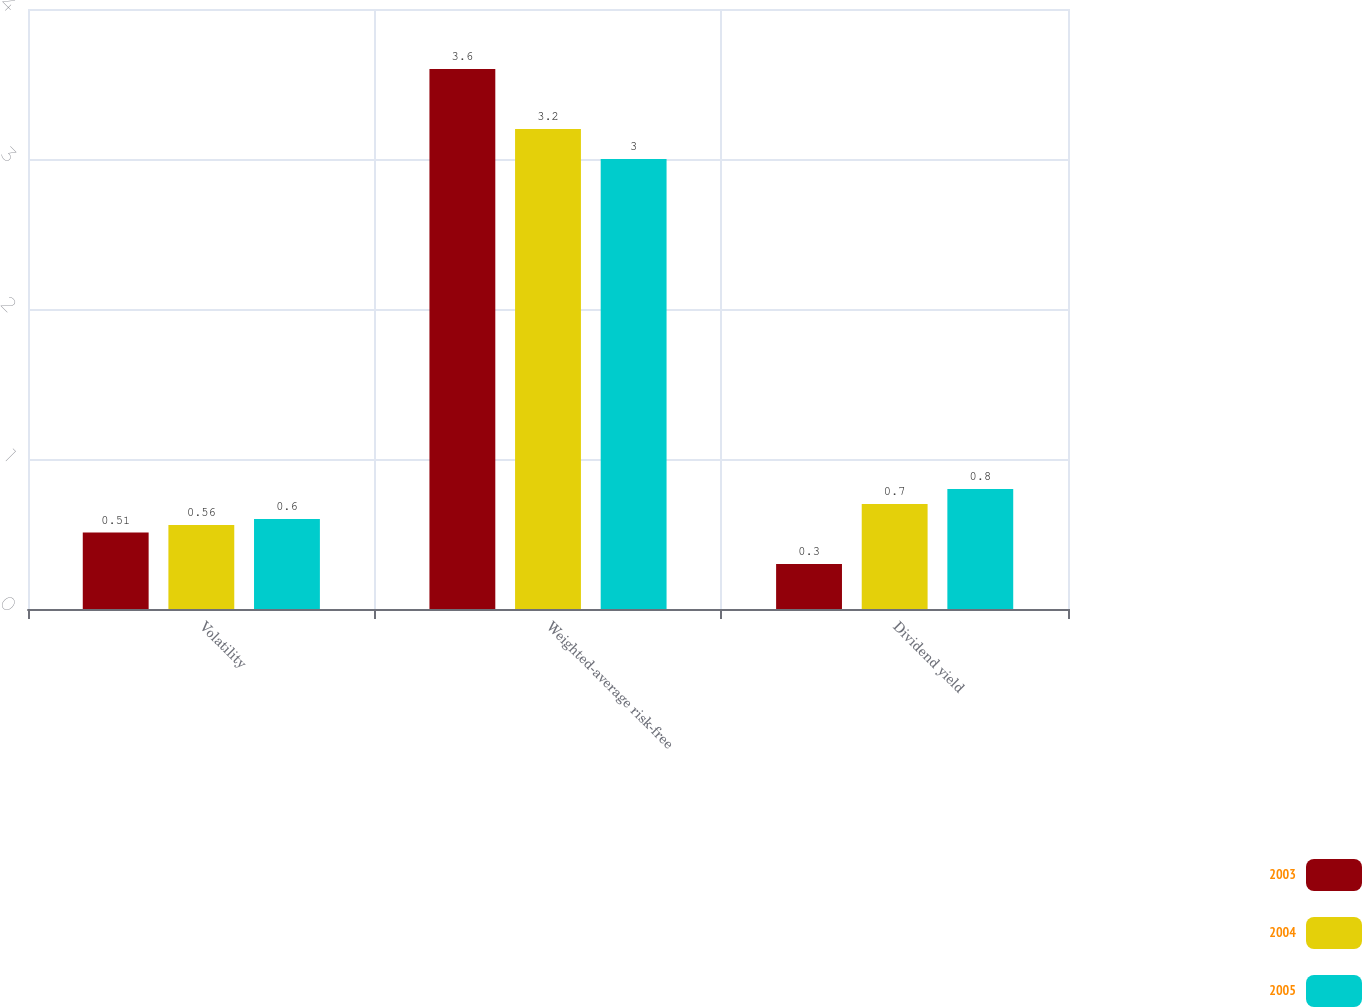Convert chart to OTSL. <chart><loc_0><loc_0><loc_500><loc_500><stacked_bar_chart><ecel><fcel>Volatility<fcel>Weighted-average risk-free<fcel>Dividend yield<nl><fcel>2003<fcel>0.51<fcel>3.6<fcel>0.3<nl><fcel>2004<fcel>0.56<fcel>3.2<fcel>0.7<nl><fcel>2005<fcel>0.6<fcel>3<fcel>0.8<nl></chart> 